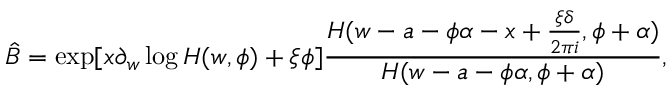<formula> <loc_0><loc_0><loc_500><loc_500>\hat { B } = \exp [ x \partial _ { w } \log H ( w , \phi ) + \xi \phi ] \frac { H ( w - a - \phi \alpha - x + \frac { \xi \delta } { 2 \pi i } , \phi + \alpha ) } { H ( w - a - \phi \alpha , \phi + \alpha ) } ,</formula> 